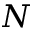Convert formula to latex. <formula><loc_0><loc_0><loc_500><loc_500>N</formula> 